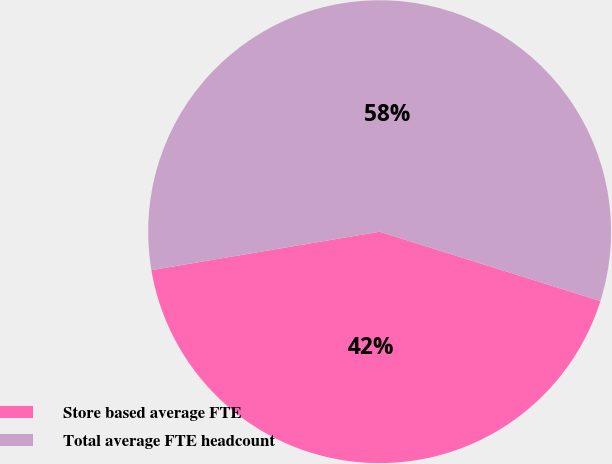Convert chart to OTSL. <chart><loc_0><loc_0><loc_500><loc_500><pie_chart><fcel>Store based average FTE<fcel>Total average FTE headcount<nl><fcel>42.5%<fcel>57.5%<nl></chart> 